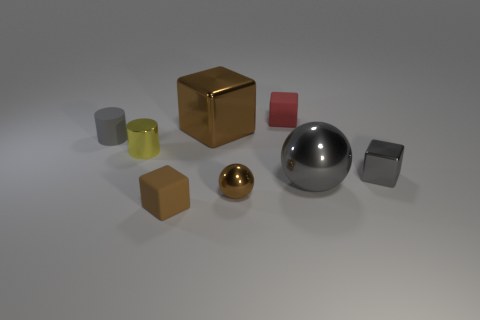What number of things are gray rubber cubes or gray metal balls?
Keep it short and to the point. 1. Is the color of the cube that is to the left of the large brown shiny block the same as the metallic cube that is behind the tiny yellow cylinder?
Offer a terse response. Yes. How many other objects are there of the same shape as the gray matte object?
Offer a very short reply. 1. Is there a object?
Make the answer very short. Yes. What number of things are tiny gray metallic cubes or matte objects that are in front of the gray block?
Ensure brevity in your answer.  2. Is the size of the gray metal object that is left of the gray metal cube the same as the tiny brown matte cube?
Your answer should be very brief. No. What number of other objects are the same size as the red cube?
Offer a very short reply. 5. The small sphere has what color?
Make the answer very short. Brown. What material is the tiny gray object that is right of the large brown metal object?
Provide a succinct answer. Metal. Are there the same number of gray objects that are behind the tiny gray cylinder and big yellow shiny things?
Make the answer very short. Yes. 